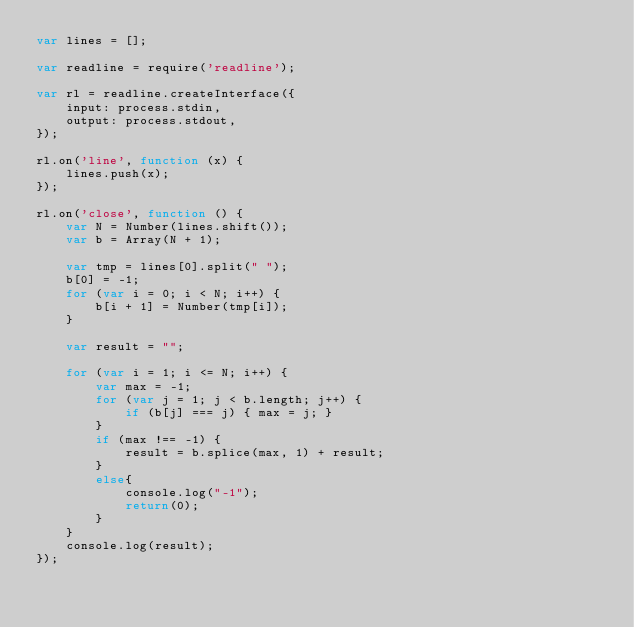Convert code to text. <code><loc_0><loc_0><loc_500><loc_500><_JavaScript_>var lines = [];

var readline = require('readline');

var rl = readline.createInterface({
    input: process.stdin,
    output: process.stdout,
});

rl.on('line', function (x) {
    lines.push(x);
});

rl.on('close', function () {
    var N = Number(lines.shift());
    var b = Array(N + 1);

    var tmp = lines[0].split(" ");
    b[0] = -1;
    for (var i = 0; i < N; i++) {
        b[i + 1] = Number(tmp[i]);
    }

    var result = "";

    for (var i = 1; i <= N; i++) {
        var max = -1;
        for (var j = 1; j < b.length; j++) {
            if (b[j] === j) { max = j; }
        }
        if (max !== -1) {
            result = b.splice(max, 1) + result;
        }
        else{
            console.log("-1");
            return(0);
        }
    }
    console.log(result);
});</code> 